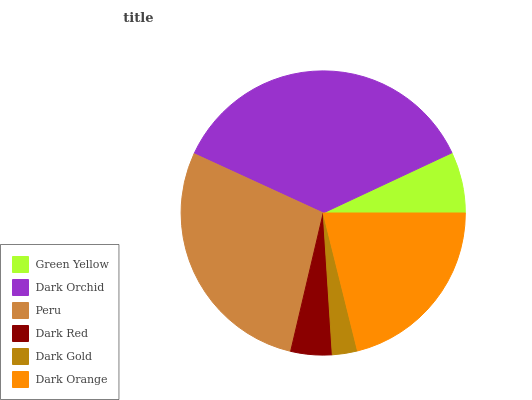Is Dark Gold the minimum?
Answer yes or no. Yes. Is Dark Orchid the maximum?
Answer yes or no. Yes. Is Peru the minimum?
Answer yes or no. No. Is Peru the maximum?
Answer yes or no. No. Is Dark Orchid greater than Peru?
Answer yes or no. Yes. Is Peru less than Dark Orchid?
Answer yes or no. Yes. Is Peru greater than Dark Orchid?
Answer yes or no. No. Is Dark Orchid less than Peru?
Answer yes or no. No. Is Dark Orange the high median?
Answer yes or no. Yes. Is Green Yellow the low median?
Answer yes or no. Yes. Is Peru the high median?
Answer yes or no. No. Is Dark Red the low median?
Answer yes or no. No. 